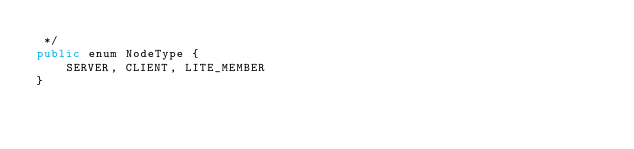<code> <loc_0><loc_0><loc_500><loc_500><_Java_> */
public enum NodeType {
    SERVER, CLIENT, LITE_MEMBER
}
</code> 